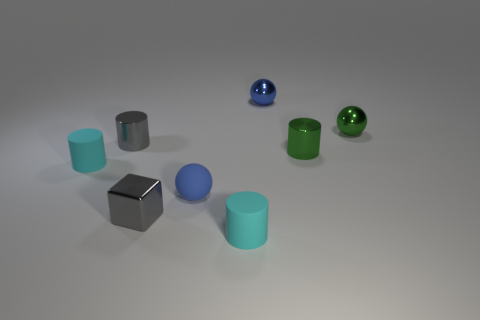Does the tiny shiny block have the same color as the metallic cylinder on the left side of the blue metallic thing?
Offer a terse response. Yes. Does the small blue rubber thing have the same shape as the small blue shiny thing?
Give a very brief answer. Yes. How many spheres are small blue objects or tiny green objects?
Offer a terse response. 3. There is a tiny cube that is made of the same material as the gray cylinder; what is its color?
Your answer should be compact. Gray. There is a metallic thing that is left of the cube; is its size the same as the tiny gray metallic block?
Offer a terse response. Yes. Are the small green cylinder and the small cyan cylinder that is on the right side of the gray shiny cylinder made of the same material?
Keep it short and to the point. No. There is a shiny cylinder that is to the right of the blue metal sphere; what color is it?
Give a very brief answer. Green. Is there a blue metallic sphere behind the gray shiny thing that is behind the cube?
Make the answer very short. Yes. There is a tiny metal thing that is right of the small green cylinder; is its color the same as the shiny cylinder to the right of the gray block?
Your response must be concise. Yes. There is a small green ball; how many tiny green metallic cylinders are on the left side of it?
Ensure brevity in your answer.  1. 